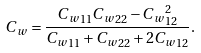<formula> <loc_0><loc_0><loc_500><loc_500>C _ { w } = \frac { { C _ { w } } _ { 1 1 } { C _ { w } } _ { 2 2 } - { C _ { w } } ^ { 2 } _ { 1 2 } } { { C _ { w } } _ { 1 1 } + { C _ { w } } _ { 2 2 } + 2 { C _ { w } } _ { 1 2 } } .</formula> 